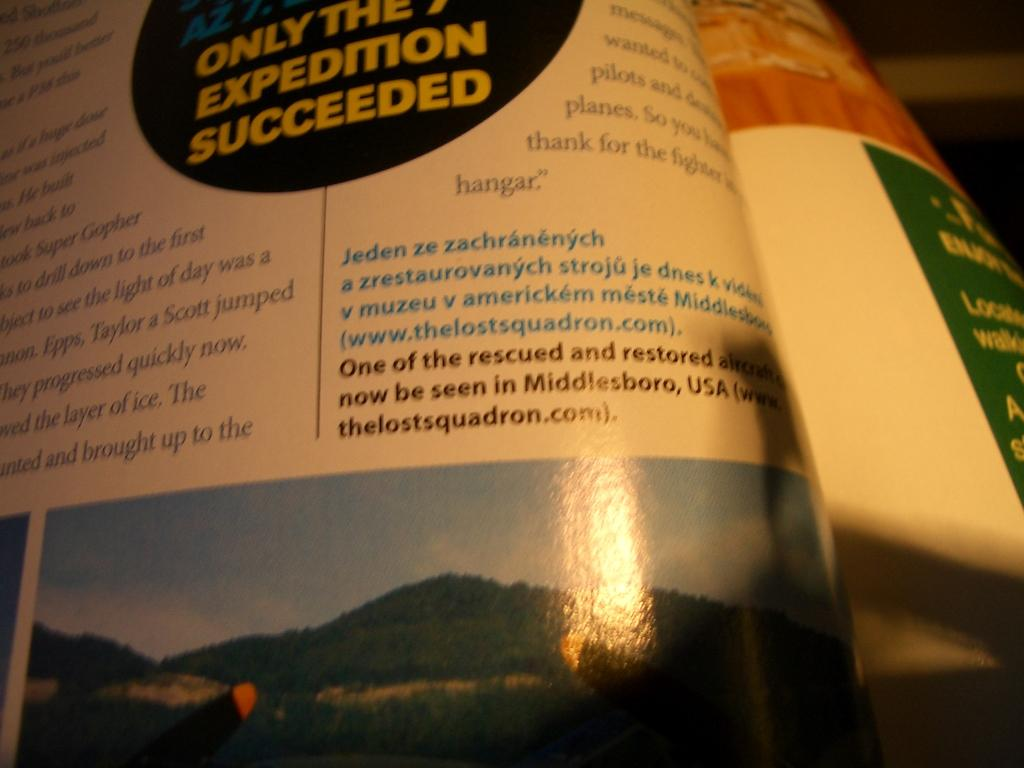Provide a one-sentence caption for the provided image. a book that has a section that says 'only the 7th expedition succeeded'. 